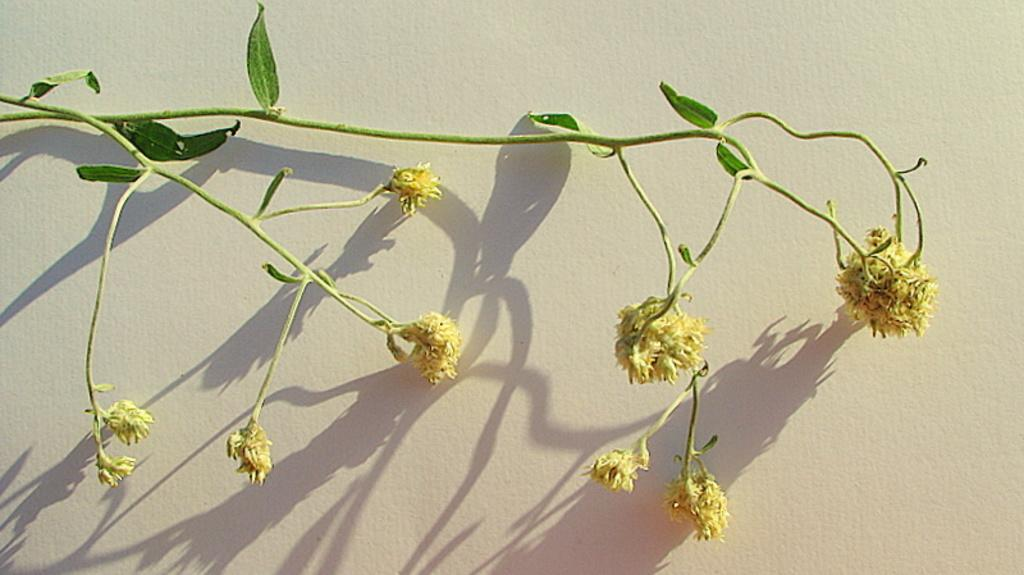What is located in the center of the image? There are flowers, leaves, and stems of a plant in the center of the image. What type of plant is depicted in the image? The image shows a plant with flowers, leaves, and stems. What can be seen behind the plant in the image? There is a wall behind the plant. What color is the wall in the image? The wall is painted white. Can you see a mountain in the background of the image? There is no mountain visible in the image; it features a plant with flowers, leaves, and stems in front of a white wall. 